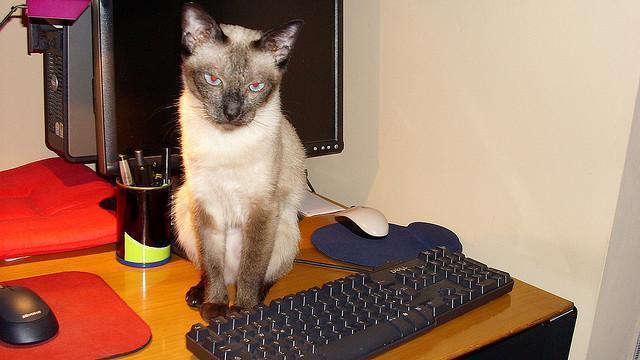How many cats are there?
Give a very brief answer. 1. 